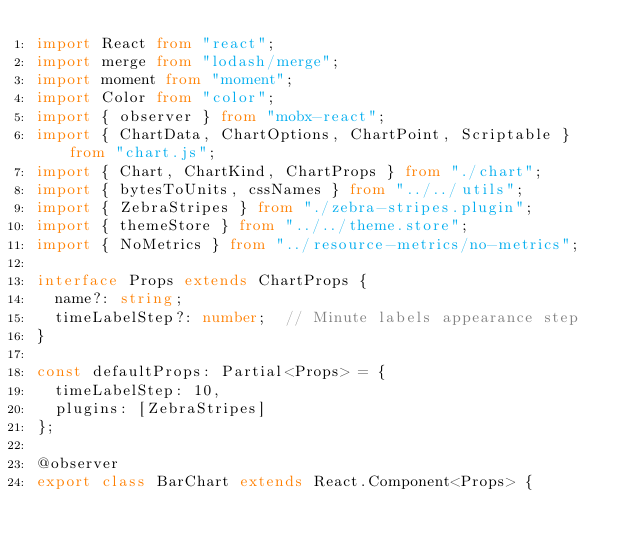Convert code to text. <code><loc_0><loc_0><loc_500><loc_500><_TypeScript_>import React from "react";
import merge from "lodash/merge";
import moment from "moment";
import Color from "color";
import { observer } from "mobx-react";
import { ChartData, ChartOptions, ChartPoint, Scriptable } from "chart.js";
import { Chart, ChartKind, ChartProps } from "./chart";
import { bytesToUnits, cssNames } from "../../utils";
import { ZebraStripes } from "./zebra-stripes.plugin";
import { themeStore } from "../../theme.store";
import { NoMetrics } from "../resource-metrics/no-metrics";

interface Props extends ChartProps {
  name?: string;
  timeLabelStep?: number;  // Minute labels appearance step
}

const defaultProps: Partial<Props> = {
  timeLabelStep: 10,
  plugins: [ZebraStripes]
};

@observer
export class BarChart extends React.Component<Props> {</code> 